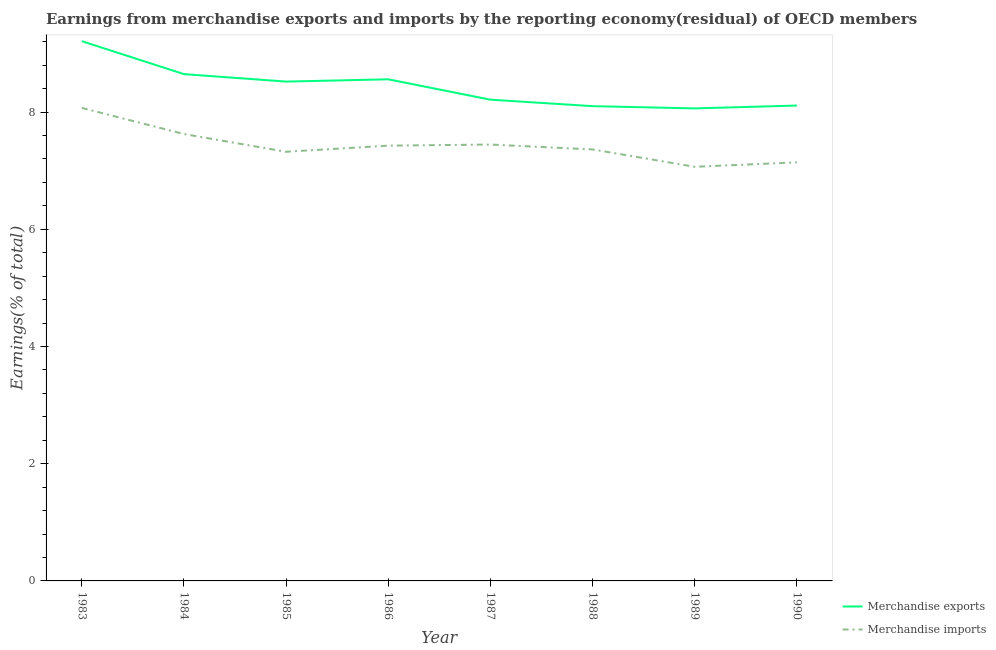Does the line corresponding to earnings from merchandise imports intersect with the line corresponding to earnings from merchandise exports?
Ensure brevity in your answer.  No. What is the earnings from merchandise exports in 1988?
Ensure brevity in your answer.  8.1. Across all years, what is the maximum earnings from merchandise imports?
Offer a very short reply. 8.07. Across all years, what is the minimum earnings from merchandise imports?
Provide a succinct answer. 7.07. In which year was the earnings from merchandise exports maximum?
Provide a short and direct response. 1983. What is the total earnings from merchandise imports in the graph?
Provide a succinct answer. 59.46. What is the difference between the earnings from merchandise exports in 1984 and that in 1989?
Make the answer very short. 0.58. What is the difference between the earnings from merchandise imports in 1989 and the earnings from merchandise exports in 1988?
Make the answer very short. -1.03. What is the average earnings from merchandise imports per year?
Make the answer very short. 7.43. In the year 1983, what is the difference between the earnings from merchandise imports and earnings from merchandise exports?
Make the answer very short. -1.14. In how many years, is the earnings from merchandise exports greater than 6.4 %?
Your answer should be very brief. 8. What is the ratio of the earnings from merchandise exports in 1988 to that in 1990?
Give a very brief answer. 1. What is the difference between the highest and the second highest earnings from merchandise exports?
Provide a succinct answer. 0.56. What is the difference between the highest and the lowest earnings from merchandise imports?
Your answer should be very brief. 1. Is the sum of the earnings from merchandise imports in 1983 and 1988 greater than the maximum earnings from merchandise exports across all years?
Your answer should be compact. Yes. Does the earnings from merchandise imports monotonically increase over the years?
Give a very brief answer. No. How many years are there in the graph?
Keep it short and to the point. 8. What is the difference between two consecutive major ticks on the Y-axis?
Your response must be concise. 2. Does the graph contain grids?
Keep it short and to the point. No. Where does the legend appear in the graph?
Keep it short and to the point. Bottom right. How many legend labels are there?
Give a very brief answer. 2. How are the legend labels stacked?
Provide a short and direct response. Vertical. What is the title of the graph?
Make the answer very short. Earnings from merchandise exports and imports by the reporting economy(residual) of OECD members. What is the label or title of the Y-axis?
Make the answer very short. Earnings(% of total). What is the Earnings(% of total) in Merchandise exports in 1983?
Offer a very short reply. 9.21. What is the Earnings(% of total) of Merchandise imports in 1983?
Your answer should be compact. 8.07. What is the Earnings(% of total) of Merchandise exports in 1984?
Keep it short and to the point. 8.65. What is the Earnings(% of total) in Merchandise imports in 1984?
Offer a very short reply. 7.63. What is the Earnings(% of total) in Merchandise exports in 1985?
Make the answer very short. 8.52. What is the Earnings(% of total) of Merchandise imports in 1985?
Offer a very short reply. 7.32. What is the Earnings(% of total) in Merchandise exports in 1986?
Provide a short and direct response. 8.56. What is the Earnings(% of total) of Merchandise imports in 1986?
Your response must be concise. 7.43. What is the Earnings(% of total) in Merchandise exports in 1987?
Ensure brevity in your answer.  8.21. What is the Earnings(% of total) in Merchandise imports in 1987?
Your answer should be very brief. 7.45. What is the Earnings(% of total) of Merchandise exports in 1988?
Offer a very short reply. 8.1. What is the Earnings(% of total) of Merchandise imports in 1988?
Your answer should be very brief. 7.36. What is the Earnings(% of total) in Merchandise exports in 1989?
Keep it short and to the point. 8.06. What is the Earnings(% of total) in Merchandise imports in 1989?
Your answer should be compact. 7.07. What is the Earnings(% of total) in Merchandise exports in 1990?
Your answer should be compact. 8.11. What is the Earnings(% of total) of Merchandise imports in 1990?
Your response must be concise. 7.14. Across all years, what is the maximum Earnings(% of total) in Merchandise exports?
Provide a short and direct response. 9.21. Across all years, what is the maximum Earnings(% of total) in Merchandise imports?
Offer a terse response. 8.07. Across all years, what is the minimum Earnings(% of total) of Merchandise exports?
Provide a succinct answer. 8.06. Across all years, what is the minimum Earnings(% of total) of Merchandise imports?
Provide a short and direct response. 7.07. What is the total Earnings(% of total) of Merchandise exports in the graph?
Ensure brevity in your answer.  67.42. What is the total Earnings(% of total) in Merchandise imports in the graph?
Offer a terse response. 59.46. What is the difference between the Earnings(% of total) in Merchandise exports in 1983 and that in 1984?
Ensure brevity in your answer.  0.56. What is the difference between the Earnings(% of total) of Merchandise imports in 1983 and that in 1984?
Your answer should be compact. 0.45. What is the difference between the Earnings(% of total) of Merchandise exports in 1983 and that in 1985?
Offer a terse response. 0.69. What is the difference between the Earnings(% of total) of Merchandise imports in 1983 and that in 1985?
Ensure brevity in your answer.  0.75. What is the difference between the Earnings(% of total) of Merchandise exports in 1983 and that in 1986?
Ensure brevity in your answer.  0.65. What is the difference between the Earnings(% of total) in Merchandise imports in 1983 and that in 1986?
Provide a succinct answer. 0.64. What is the difference between the Earnings(% of total) of Merchandise exports in 1983 and that in 1987?
Make the answer very short. 1. What is the difference between the Earnings(% of total) of Merchandise imports in 1983 and that in 1987?
Keep it short and to the point. 0.63. What is the difference between the Earnings(% of total) of Merchandise exports in 1983 and that in 1988?
Your answer should be compact. 1.11. What is the difference between the Earnings(% of total) of Merchandise imports in 1983 and that in 1988?
Provide a succinct answer. 0.71. What is the difference between the Earnings(% of total) of Merchandise exports in 1983 and that in 1989?
Keep it short and to the point. 1.15. What is the difference between the Earnings(% of total) in Merchandise imports in 1983 and that in 1989?
Provide a succinct answer. 1. What is the difference between the Earnings(% of total) of Merchandise exports in 1983 and that in 1990?
Your answer should be very brief. 1.1. What is the difference between the Earnings(% of total) in Merchandise imports in 1983 and that in 1990?
Make the answer very short. 0.93. What is the difference between the Earnings(% of total) in Merchandise exports in 1984 and that in 1985?
Provide a succinct answer. 0.13. What is the difference between the Earnings(% of total) of Merchandise imports in 1984 and that in 1985?
Ensure brevity in your answer.  0.3. What is the difference between the Earnings(% of total) of Merchandise exports in 1984 and that in 1986?
Provide a short and direct response. 0.09. What is the difference between the Earnings(% of total) in Merchandise imports in 1984 and that in 1986?
Make the answer very short. 0.2. What is the difference between the Earnings(% of total) of Merchandise exports in 1984 and that in 1987?
Your answer should be very brief. 0.44. What is the difference between the Earnings(% of total) in Merchandise imports in 1984 and that in 1987?
Offer a terse response. 0.18. What is the difference between the Earnings(% of total) in Merchandise exports in 1984 and that in 1988?
Ensure brevity in your answer.  0.55. What is the difference between the Earnings(% of total) in Merchandise imports in 1984 and that in 1988?
Ensure brevity in your answer.  0.26. What is the difference between the Earnings(% of total) of Merchandise exports in 1984 and that in 1989?
Your answer should be very brief. 0.58. What is the difference between the Earnings(% of total) of Merchandise imports in 1984 and that in 1989?
Offer a terse response. 0.56. What is the difference between the Earnings(% of total) of Merchandise exports in 1984 and that in 1990?
Ensure brevity in your answer.  0.54. What is the difference between the Earnings(% of total) of Merchandise imports in 1984 and that in 1990?
Provide a short and direct response. 0.48. What is the difference between the Earnings(% of total) in Merchandise exports in 1985 and that in 1986?
Offer a terse response. -0.04. What is the difference between the Earnings(% of total) in Merchandise imports in 1985 and that in 1986?
Keep it short and to the point. -0.1. What is the difference between the Earnings(% of total) of Merchandise exports in 1985 and that in 1987?
Offer a terse response. 0.31. What is the difference between the Earnings(% of total) in Merchandise imports in 1985 and that in 1987?
Ensure brevity in your answer.  -0.12. What is the difference between the Earnings(% of total) in Merchandise exports in 1985 and that in 1988?
Keep it short and to the point. 0.42. What is the difference between the Earnings(% of total) of Merchandise imports in 1985 and that in 1988?
Offer a very short reply. -0.04. What is the difference between the Earnings(% of total) of Merchandise exports in 1985 and that in 1989?
Make the answer very short. 0.46. What is the difference between the Earnings(% of total) in Merchandise imports in 1985 and that in 1989?
Offer a very short reply. 0.26. What is the difference between the Earnings(% of total) of Merchandise exports in 1985 and that in 1990?
Provide a short and direct response. 0.41. What is the difference between the Earnings(% of total) of Merchandise imports in 1985 and that in 1990?
Keep it short and to the point. 0.18. What is the difference between the Earnings(% of total) of Merchandise exports in 1986 and that in 1987?
Keep it short and to the point. 0.35. What is the difference between the Earnings(% of total) of Merchandise imports in 1986 and that in 1987?
Your answer should be compact. -0.02. What is the difference between the Earnings(% of total) in Merchandise exports in 1986 and that in 1988?
Provide a succinct answer. 0.46. What is the difference between the Earnings(% of total) in Merchandise imports in 1986 and that in 1988?
Your response must be concise. 0.06. What is the difference between the Earnings(% of total) of Merchandise exports in 1986 and that in 1989?
Your answer should be compact. 0.5. What is the difference between the Earnings(% of total) of Merchandise imports in 1986 and that in 1989?
Ensure brevity in your answer.  0.36. What is the difference between the Earnings(% of total) of Merchandise exports in 1986 and that in 1990?
Keep it short and to the point. 0.45. What is the difference between the Earnings(% of total) in Merchandise imports in 1986 and that in 1990?
Your response must be concise. 0.29. What is the difference between the Earnings(% of total) in Merchandise exports in 1987 and that in 1988?
Your answer should be compact. 0.11. What is the difference between the Earnings(% of total) of Merchandise imports in 1987 and that in 1988?
Your response must be concise. 0.08. What is the difference between the Earnings(% of total) in Merchandise exports in 1987 and that in 1989?
Your answer should be compact. 0.15. What is the difference between the Earnings(% of total) of Merchandise imports in 1987 and that in 1989?
Make the answer very short. 0.38. What is the difference between the Earnings(% of total) of Merchandise exports in 1987 and that in 1990?
Offer a terse response. 0.1. What is the difference between the Earnings(% of total) of Merchandise imports in 1987 and that in 1990?
Offer a very short reply. 0.3. What is the difference between the Earnings(% of total) in Merchandise exports in 1988 and that in 1989?
Keep it short and to the point. 0.04. What is the difference between the Earnings(% of total) in Merchandise imports in 1988 and that in 1989?
Ensure brevity in your answer.  0.3. What is the difference between the Earnings(% of total) of Merchandise exports in 1988 and that in 1990?
Your answer should be compact. -0.01. What is the difference between the Earnings(% of total) in Merchandise imports in 1988 and that in 1990?
Provide a short and direct response. 0.22. What is the difference between the Earnings(% of total) of Merchandise exports in 1989 and that in 1990?
Ensure brevity in your answer.  -0.05. What is the difference between the Earnings(% of total) in Merchandise imports in 1989 and that in 1990?
Make the answer very short. -0.08. What is the difference between the Earnings(% of total) of Merchandise exports in 1983 and the Earnings(% of total) of Merchandise imports in 1984?
Offer a terse response. 1.58. What is the difference between the Earnings(% of total) in Merchandise exports in 1983 and the Earnings(% of total) in Merchandise imports in 1985?
Give a very brief answer. 1.89. What is the difference between the Earnings(% of total) in Merchandise exports in 1983 and the Earnings(% of total) in Merchandise imports in 1986?
Provide a succinct answer. 1.78. What is the difference between the Earnings(% of total) in Merchandise exports in 1983 and the Earnings(% of total) in Merchandise imports in 1987?
Your response must be concise. 1.76. What is the difference between the Earnings(% of total) of Merchandise exports in 1983 and the Earnings(% of total) of Merchandise imports in 1988?
Provide a succinct answer. 1.85. What is the difference between the Earnings(% of total) of Merchandise exports in 1983 and the Earnings(% of total) of Merchandise imports in 1989?
Give a very brief answer. 2.14. What is the difference between the Earnings(% of total) of Merchandise exports in 1983 and the Earnings(% of total) of Merchandise imports in 1990?
Your answer should be very brief. 2.07. What is the difference between the Earnings(% of total) in Merchandise exports in 1984 and the Earnings(% of total) in Merchandise imports in 1985?
Your answer should be very brief. 1.32. What is the difference between the Earnings(% of total) of Merchandise exports in 1984 and the Earnings(% of total) of Merchandise imports in 1986?
Give a very brief answer. 1.22. What is the difference between the Earnings(% of total) of Merchandise exports in 1984 and the Earnings(% of total) of Merchandise imports in 1987?
Make the answer very short. 1.2. What is the difference between the Earnings(% of total) of Merchandise exports in 1984 and the Earnings(% of total) of Merchandise imports in 1988?
Provide a succinct answer. 1.29. What is the difference between the Earnings(% of total) of Merchandise exports in 1984 and the Earnings(% of total) of Merchandise imports in 1989?
Provide a short and direct response. 1.58. What is the difference between the Earnings(% of total) in Merchandise exports in 1984 and the Earnings(% of total) in Merchandise imports in 1990?
Offer a very short reply. 1.51. What is the difference between the Earnings(% of total) in Merchandise exports in 1985 and the Earnings(% of total) in Merchandise imports in 1986?
Give a very brief answer. 1.09. What is the difference between the Earnings(% of total) in Merchandise exports in 1985 and the Earnings(% of total) in Merchandise imports in 1987?
Your response must be concise. 1.07. What is the difference between the Earnings(% of total) in Merchandise exports in 1985 and the Earnings(% of total) in Merchandise imports in 1988?
Provide a succinct answer. 1.16. What is the difference between the Earnings(% of total) in Merchandise exports in 1985 and the Earnings(% of total) in Merchandise imports in 1989?
Your answer should be very brief. 1.45. What is the difference between the Earnings(% of total) in Merchandise exports in 1985 and the Earnings(% of total) in Merchandise imports in 1990?
Your answer should be very brief. 1.38. What is the difference between the Earnings(% of total) of Merchandise exports in 1986 and the Earnings(% of total) of Merchandise imports in 1987?
Offer a very short reply. 1.11. What is the difference between the Earnings(% of total) of Merchandise exports in 1986 and the Earnings(% of total) of Merchandise imports in 1988?
Keep it short and to the point. 1.2. What is the difference between the Earnings(% of total) of Merchandise exports in 1986 and the Earnings(% of total) of Merchandise imports in 1989?
Offer a terse response. 1.49. What is the difference between the Earnings(% of total) of Merchandise exports in 1986 and the Earnings(% of total) of Merchandise imports in 1990?
Your answer should be very brief. 1.42. What is the difference between the Earnings(% of total) of Merchandise exports in 1987 and the Earnings(% of total) of Merchandise imports in 1988?
Your answer should be compact. 0.85. What is the difference between the Earnings(% of total) in Merchandise exports in 1987 and the Earnings(% of total) in Merchandise imports in 1989?
Provide a short and direct response. 1.15. What is the difference between the Earnings(% of total) of Merchandise exports in 1987 and the Earnings(% of total) of Merchandise imports in 1990?
Ensure brevity in your answer.  1.07. What is the difference between the Earnings(% of total) of Merchandise exports in 1988 and the Earnings(% of total) of Merchandise imports in 1989?
Your response must be concise. 1.03. What is the difference between the Earnings(% of total) in Merchandise exports in 1988 and the Earnings(% of total) in Merchandise imports in 1990?
Keep it short and to the point. 0.96. What is the difference between the Earnings(% of total) in Merchandise exports in 1989 and the Earnings(% of total) in Merchandise imports in 1990?
Provide a short and direct response. 0.92. What is the average Earnings(% of total) of Merchandise exports per year?
Offer a terse response. 8.43. What is the average Earnings(% of total) in Merchandise imports per year?
Keep it short and to the point. 7.43. In the year 1983, what is the difference between the Earnings(% of total) in Merchandise exports and Earnings(% of total) in Merchandise imports?
Provide a short and direct response. 1.14. In the year 1984, what is the difference between the Earnings(% of total) of Merchandise exports and Earnings(% of total) of Merchandise imports?
Make the answer very short. 1.02. In the year 1985, what is the difference between the Earnings(% of total) of Merchandise exports and Earnings(% of total) of Merchandise imports?
Make the answer very short. 1.2. In the year 1986, what is the difference between the Earnings(% of total) of Merchandise exports and Earnings(% of total) of Merchandise imports?
Make the answer very short. 1.13. In the year 1987, what is the difference between the Earnings(% of total) in Merchandise exports and Earnings(% of total) in Merchandise imports?
Your response must be concise. 0.77. In the year 1988, what is the difference between the Earnings(% of total) of Merchandise exports and Earnings(% of total) of Merchandise imports?
Provide a short and direct response. 0.74. In the year 1989, what is the difference between the Earnings(% of total) in Merchandise exports and Earnings(% of total) in Merchandise imports?
Ensure brevity in your answer.  1. In the year 1990, what is the difference between the Earnings(% of total) in Merchandise exports and Earnings(% of total) in Merchandise imports?
Keep it short and to the point. 0.97. What is the ratio of the Earnings(% of total) of Merchandise exports in 1983 to that in 1984?
Your response must be concise. 1.06. What is the ratio of the Earnings(% of total) in Merchandise imports in 1983 to that in 1984?
Make the answer very short. 1.06. What is the ratio of the Earnings(% of total) of Merchandise exports in 1983 to that in 1985?
Your answer should be compact. 1.08. What is the ratio of the Earnings(% of total) in Merchandise imports in 1983 to that in 1985?
Your response must be concise. 1.1. What is the ratio of the Earnings(% of total) in Merchandise exports in 1983 to that in 1986?
Your answer should be compact. 1.08. What is the ratio of the Earnings(% of total) of Merchandise imports in 1983 to that in 1986?
Provide a succinct answer. 1.09. What is the ratio of the Earnings(% of total) in Merchandise exports in 1983 to that in 1987?
Offer a very short reply. 1.12. What is the ratio of the Earnings(% of total) in Merchandise imports in 1983 to that in 1987?
Your answer should be very brief. 1.08. What is the ratio of the Earnings(% of total) of Merchandise exports in 1983 to that in 1988?
Offer a very short reply. 1.14. What is the ratio of the Earnings(% of total) of Merchandise imports in 1983 to that in 1988?
Offer a terse response. 1.1. What is the ratio of the Earnings(% of total) of Merchandise exports in 1983 to that in 1989?
Give a very brief answer. 1.14. What is the ratio of the Earnings(% of total) of Merchandise imports in 1983 to that in 1989?
Make the answer very short. 1.14. What is the ratio of the Earnings(% of total) of Merchandise exports in 1983 to that in 1990?
Provide a short and direct response. 1.14. What is the ratio of the Earnings(% of total) in Merchandise imports in 1983 to that in 1990?
Give a very brief answer. 1.13. What is the ratio of the Earnings(% of total) in Merchandise imports in 1984 to that in 1985?
Your response must be concise. 1.04. What is the ratio of the Earnings(% of total) in Merchandise exports in 1984 to that in 1986?
Your answer should be compact. 1.01. What is the ratio of the Earnings(% of total) of Merchandise imports in 1984 to that in 1986?
Your response must be concise. 1.03. What is the ratio of the Earnings(% of total) in Merchandise exports in 1984 to that in 1987?
Provide a succinct answer. 1.05. What is the ratio of the Earnings(% of total) of Merchandise imports in 1984 to that in 1987?
Provide a short and direct response. 1.02. What is the ratio of the Earnings(% of total) of Merchandise exports in 1984 to that in 1988?
Your answer should be very brief. 1.07. What is the ratio of the Earnings(% of total) in Merchandise imports in 1984 to that in 1988?
Your answer should be compact. 1.04. What is the ratio of the Earnings(% of total) in Merchandise exports in 1984 to that in 1989?
Provide a succinct answer. 1.07. What is the ratio of the Earnings(% of total) in Merchandise imports in 1984 to that in 1989?
Your answer should be very brief. 1.08. What is the ratio of the Earnings(% of total) in Merchandise exports in 1984 to that in 1990?
Offer a terse response. 1.07. What is the ratio of the Earnings(% of total) in Merchandise imports in 1984 to that in 1990?
Your answer should be very brief. 1.07. What is the ratio of the Earnings(% of total) of Merchandise imports in 1985 to that in 1986?
Ensure brevity in your answer.  0.99. What is the ratio of the Earnings(% of total) of Merchandise exports in 1985 to that in 1987?
Provide a short and direct response. 1.04. What is the ratio of the Earnings(% of total) of Merchandise imports in 1985 to that in 1987?
Provide a short and direct response. 0.98. What is the ratio of the Earnings(% of total) in Merchandise exports in 1985 to that in 1988?
Offer a terse response. 1.05. What is the ratio of the Earnings(% of total) in Merchandise exports in 1985 to that in 1989?
Make the answer very short. 1.06. What is the ratio of the Earnings(% of total) in Merchandise imports in 1985 to that in 1989?
Ensure brevity in your answer.  1.04. What is the ratio of the Earnings(% of total) in Merchandise exports in 1985 to that in 1990?
Ensure brevity in your answer.  1.05. What is the ratio of the Earnings(% of total) of Merchandise imports in 1985 to that in 1990?
Offer a terse response. 1.03. What is the ratio of the Earnings(% of total) in Merchandise exports in 1986 to that in 1987?
Offer a terse response. 1.04. What is the ratio of the Earnings(% of total) in Merchandise exports in 1986 to that in 1988?
Keep it short and to the point. 1.06. What is the ratio of the Earnings(% of total) in Merchandise imports in 1986 to that in 1988?
Your answer should be very brief. 1.01. What is the ratio of the Earnings(% of total) of Merchandise exports in 1986 to that in 1989?
Give a very brief answer. 1.06. What is the ratio of the Earnings(% of total) of Merchandise imports in 1986 to that in 1989?
Give a very brief answer. 1.05. What is the ratio of the Earnings(% of total) of Merchandise exports in 1986 to that in 1990?
Offer a very short reply. 1.06. What is the ratio of the Earnings(% of total) of Merchandise imports in 1986 to that in 1990?
Offer a terse response. 1.04. What is the ratio of the Earnings(% of total) of Merchandise exports in 1987 to that in 1988?
Make the answer very short. 1.01. What is the ratio of the Earnings(% of total) of Merchandise imports in 1987 to that in 1988?
Your answer should be very brief. 1.01. What is the ratio of the Earnings(% of total) of Merchandise exports in 1987 to that in 1989?
Give a very brief answer. 1.02. What is the ratio of the Earnings(% of total) in Merchandise imports in 1987 to that in 1989?
Your answer should be very brief. 1.05. What is the ratio of the Earnings(% of total) of Merchandise exports in 1987 to that in 1990?
Offer a terse response. 1.01. What is the ratio of the Earnings(% of total) of Merchandise imports in 1987 to that in 1990?
Your answer should be very brief. 1.04. What is the ratio of the Earnings(% of total) of Merchandise exports in 1988 to that in 1989?
Ensure brevity in your answer.  1. What is the ratio of the Earnings(% of total) of Merchandise imports in 1988 to that in 1989?
Make the answer very short. 1.04. What is the ratio of the Earnings(% of total) in Merchandise exports in 1988 to that in 1990?
Provide a short and direct response. 1. What is the ratio of the Earnings(% of total) of Merchandise imports in 1988 to that in 1990?
Your answer should be very brief. 1.03. What is the ratio of the Earnings(% of total) in Merchandise imports in 1989 to that in 1990?
Your answer should be very brief. 0.99. What is the difference between the highest and the second highest Earnings(% of total) in Merchandise exports?
Provide a short and direct response. 0.56. What is the difference between the highest and the second highest Earnings(% of total) in Merchandise imports?
Offer a very short reply. 0.45. What is the difference between the highest and the lowest Earnings(% of total) of Merchandise exports?
Make the answer very short. 1.15. What is the difference between the highest and the lowest Earnings(% of total) of Merchandise imports?
Offer a very short reply. 1. 